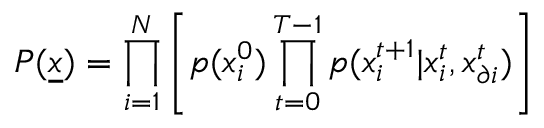Convert formula to latex. <formula><loc_0><loc_0><loc_500><loc_500>P ( \underline { x } ) = \prod _ { i = 1 } ^ { N } \left [ p ( x _ { i } ^ { 0 } ) \prod _ { t = 0 } ^ { T - 1 } p ( x _ { i } ^ { t + 1 } | x _ { i } ^ { t } , x _ { \partial i } ^ { t } ) \right ]</formula> 